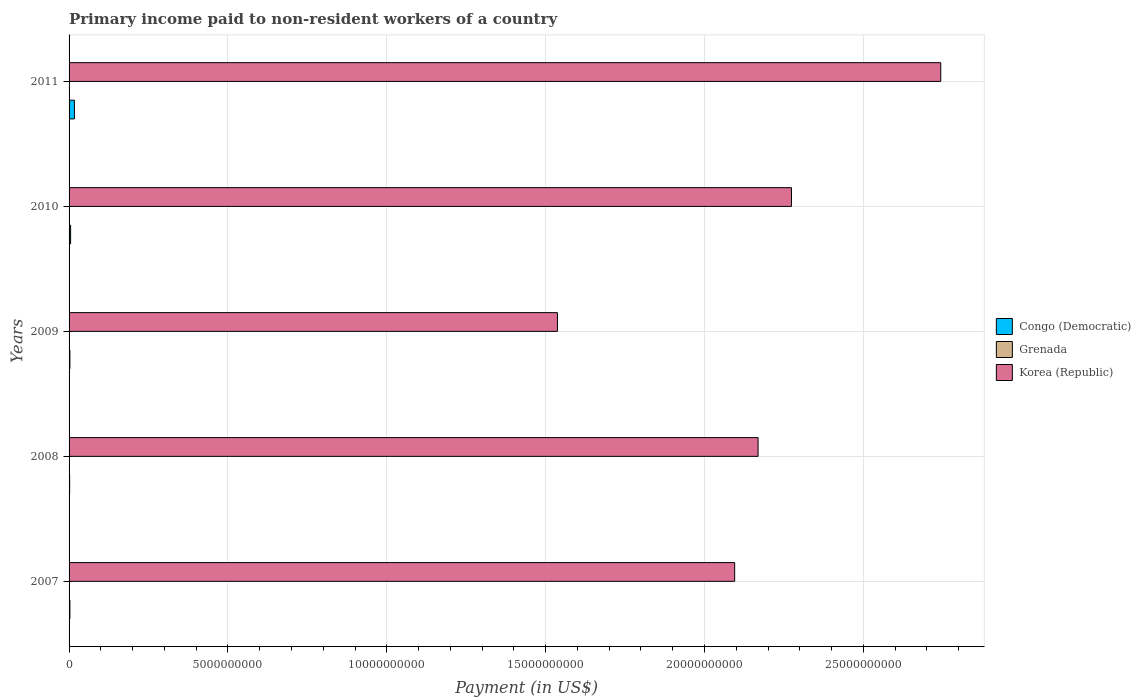How many different coloured bars are there?
Provide a short and direct response. 3. How many bars are there on the 1st tick from the top?
Your response must be concise. 3. How many bars are there on the 5th tick from the bottom?
Your response must be concise. 3. In how many cases, is the number of bars for a given year not equal to the number of legend labels?
Your answer should be very brief. 0. What is the amount paid to workers in Congo (Democratic) in 2009?
Offer a very short reply. 2.60e+07. Across all years, what is the maximum amount paid to workers in Grenada?
Give a very brief answer. 1.37e+07. Across all years, what is the minimum amount paid to workers in Grenada?
Offer a very short reply. 5.77e+06. In which year was the amount paid to workers in Congo (Democratic) minimum?
Give a very brief answer. 2008. What is the total amount paid to workers in Congo (Democratic) in the graph?
Provide a short and direct response. 2.86e+08. What is the difference between the amount paid to workers in Korea (Republic) in 2007 and that in 2011?
Offer a terse response. -6.49e+09. What is the difference between the amount paid to workers in Congo (Democratic) in 2011 and the amount paid to workers in Korea (Republic) in 2008?
Make the answer very short. -2.15e+1. What is the average amount paid to workers in Congo (Democratic) per year?
Provide a short and direct response. 5.73e+07. In the year 2011, what is the difference between the amount paid to workers in Korea (Republic) and amount paid to workers in Grenada?
Your response must be concise. 2.74e+1. In how many years, is the amount paid to workers in Korea (Republic) greater than 25000000000 US$?
Offer a very short reply. 1. What is the ratio of the amount paid to workers in Congo (Democratic) in 2009 to that in 2011?
Offer a very short reply. 0.15. What is the difference between the highest and the second highest amount paid to workers in Grenada?
Provide a short and direct response. 5.54e+06. What is the difference between the highest and the lowest amount paid to workers in Congo (Democratic)?
Your answer should be very brief. 1.50e+08. In how many years, is the amount paid to workers in Korea (Republic) greater than the average amount paid to workers in Korea (Republic) taken over all years?
Your response must be concise. 3. What does the 2nd bar from the top in 2010 represents?
Make the answer very short. Grenada. What does the 1st bar from the bottom in 2007 represents?
Offer a terse response. Congo (Democratic). Are all the bars in the graph horizontal?
Your response must be concise. Yes. How many years are there in the graph?
Make the answer very short. 5. Are the values on the major ticks of X-axis written in scientific E-notation?
Make the answer very short. No. Does the graph contain grids?
Give a very brief answer. Yes. How many legend labels are there?
Provide a short and direct response. 3. What is the title of the graph?
Provide a short and direct response. Primary income paid to non-resident workers of a country. What is the label or title of the X-axis?
Offer a terse response. Payment (in US$). What is the Payment (in US$) in Congo (Democratic) in 2007?
Make the answer very short. 2.60e+07. What is the Payment (in US$) of Grenada in 2007?
Your response must be concise. 1.37e+07. What is the Payment (in US$) in Korea (Republic) in 2007?
Offer a terse response. 2.09e+1. What is the Payment (in US$) in Congo (Democratic) in 2008?
Ensure brevity in your answer.  1.78e+07. What is the Payment (in US$) in Grenada in 2008?
Ensure brevity in your answer.  8.08e+06. What is the Payment (in US$) of Korea (Republic) in 2008?
Make the answer very short. 2.17e+1. What is the Payment (in US$) in Congo (Democratic) in 2009?
Offer a very short reply. 2.60e+07. What is the Payment (in US$) in Grenada in 2009?
Make the answer very short. 8.12e+06. What is the Payment (in US$) of Korea (Republic) in 2009?
Your answer should be very brief. 1.54e+1. What is the Payment (in US$) in Congo (Democratic) in 2010?
Ensure brevity in your answer.  4.83e+07. What is the Payment (in US$) in Grenada in 2010?
Provide a succinct answer. 7.15e+06. What is the Payment (in US$) in Korea (Republic) in 2010?
Your answer should be very brief. 2.27e+1. What is the Payment (in US$) of Congo (Democratic) in 2011?
Your answer should be compact. 1.68e+08. What is the Payment (in US$) in Grenada in 2011?
Your answer should be compact. 5.77e+06. What is the Payment (in US$) in Korea (Republic) in 2011?
Make the answer very short. 2.74e+1. Across all years, what is the maximum Payment (in US$) of Congo (Democratic)?
Provide a succinct answer. 1.68e+08. Across all years, what is the maximum Payment (in US$) in Grenada?
Ensure brevity in your answer.  1.37e+07. Across all years, what is the maximum Payment (in US$) of Korea (Republic)?
Keep it short and to the point. 2.74e+1. Across all years, what is the minimum Payment (in US$) of Congo (Democratic)?
Ensure brevity in your answer.  1.78e+07. Across all years, what is the minimum Payment (in US$) of Grenada?
Provide a short and direct response. 5.77e+06. Across all years, what is the minimum Payment (in US$) of Korea (Republic)?
Your answer should be compact. 1.54e+1. What is the total Payment (in US$) of Congo (Democratic) in the graph?
Ensure brevity in your answer.  2.86e+08. What is the total Payment (in US$) in Grenada in the graph?
Make the answer very short. 4.28e+07. What is the total Payment (in US$) of Korea (Republic) in the graph?
Your answer should be compact. 1.08e+11. What is the difference between the Payment (in US$) of Congo (Democratic) in 2007 and that in 2008?
Offer a terse response. 8.20e+06. What is the difference between the Payment (in US$) in Grenada in 2007 and that in 2008?
Offer a very short reply. 5.58e+06. What is the difference between the Payment (in US$) of Korea (Republic) in 2007 and that in 2008?
Your answer should be very brief. -7.37e+08. What is the difference between the Payment (in US$) in Congo (Democratic) in 2007 and that in 2009?
Provide a succinct answer. 0. What is the difference between the Payment (in US$) of Grenada in 2007 and that in 2009?
Your answer should be compact. 5.54e+06. What is the difference between the Payment (in US$) of Korea (Republic) in 2007 and that in 2009?
Make the answer very short. 5.58e+09. What is the difference between the Payment (in US$) of Congo (Democratic) in 2007 and that in 2010?
Ensure brevity in your answer.  -2.23e+07. What is the difference between the Payment (in US$) in Grenada in 2007 and that in 2010?
Keep it short and to the point. 6.51e+06. What is the difference between the Payment (in US$) of Korea (Republic) in 2007 and that in 2010?
Offer a very short reply. -1.79e+09. What is the difference between the Payment (in US$) in Congo (Democratic) in 2007 and that in 2011?
Your answer should be compact. -1.42e+08. What is the difference between the Payment (in US$) in Grenada in 2007 and that in 2011?
Your answer should be compact. 7.89e+06. What is the difference between the Payment (in US$) in Korea (Republic) in 2007 and that in 2011?
Offer a terse response. -6.49e+09. What is the difference between the Payment (in US$) of Congo (Democratic) in 2008 and that in 2009?
Offer a very short reply. -8.20e+06. What is the difference between the Payment (in US$) in Grenada in 2008 and that in 2009?
Your answer should be very brief. -4.16e+04. What is the difference between the Payment (in US$) of Korea (Republic) in 2008 and that in 2009?
Your answer should be very brief. 6.31e+09. What is the difference between the Payment (in US$) of Congo (Democratic) in 2008 and that in 2010?
Ensure brevity in your answer.  -3.05e+07. What is the difference between the Payment (in US$) in Grenada in 2008 and that in 2010?
Make the answer very short. 9.31e+05. What is the difference between the Payment (in US$) in Korea (Republic) in 2008 and that in 2010?
Provide a short and direct response. -1.05e+09. What is the difference between the Payment (in US$) in Congo (Democratic) in 2008 and that in 2011?
Your answer should be very brief. -1.50e+08. What is the difference between the Payment (in US$) of Grenada in 2008 and that in 2011?
Make the answer very short. 2.31e+06. What is the difference between the Payment (in US$) in Korea (Republic) in 2008 and that in 2011?
Offer a very short reply. -5.75e+09. What is the difference between the Payment (in US$) of Congo (Democratic) in 2009 and that in 2010?
Give a very brief answer. -2.23e+07. What is the difference between the Payment (in US$) of Grenada in 2009 and that in 2010?
Keep it short and to the point. 9.73e+05. What is the difference between the Payment (in US$) in Korea (Republic) in 2009 and that in 2010?
Provide a succinct answer. -7.37e+09. What is the difference between the Payment (in US$) of Congo (Democratic) in 2009 and that in 2011?
Provide a succinct answer. -1.42e+08. What is the difference between the Payment (in US$) of Grenada in 2009 and that in 2011?
Offer a terse response. 2.35e+06. What is the difference between the Payment (in US$) of Korea (Republic) in 2009 and that in 2011?
Keep it short and to the point. -1.21e+1. What is the difference between the Payment (in US$) in Congo (Democratic) in 2010 and that in 2011?
Your answer should be compact. -1.20e+08. What is the difference between the Payment (in US$) of Grenada in 2010 and that in 2011?
Provide a short and direct response. 1.38e+06. What is the difference between the Payment (in US$) in Korea (Republic) in 2010 and that in 2011?
Offer a very short reply. -4.70e+09. What is the difference between the Payment (in US$) in Congo (Democratic) in 2007 and the Payment (in US$) in Grenada in 2008?
Your answer should be compact. 1.79e+07. What is the difference between the Payment (in US$) of Congo (Democratic) in 2007 and the Payment (in US$) of Korea (Republic) in 2008?
Make the answer very short. -2.17e+1. What is the difference between the Payment (in US$) of Grenada in 2007 and the Payment (in US$) of Korea (Republic) in 2008?
Offer a terse response. -2.17e+1. What is the difference between the Payment (in US$) in Congo (Democratic) in 2007 and the Payment (in US$) in Grenada in 2009?
Provide a succinct answer. 1.79e+07. What is the difference between the Payment (in US$) of Congo (Democratic) in 2007 and the Payment (in US$) of Korea (Republic) in 2009?
Make the answer very short. -1.53e+1. What is the difference between the Payment (in US$) of Grenada in 2007 and the Payment (in US$) of Korea (Republic) in 2009?
Your answer should be compact. -1.54e+1. What is the difference between the Payment (in US$) of Congo (Democratic) in 2007 and the Payment (in US$) of Grenada in 2010?
Your response must be concise. 1.88e+07. What is the difference between the Payment (in US$) in Congo (Democratic) in 2007 and the Payment (in US$) in Korea (Republic) in 2010?
Your response must be concise. -2.27e+1. What is the difference between the Payment (in US$) in Grenada in 2007 and the Payment (in US$) in Korea (Republic) in 2010?
Your answer should be very brief. -2.27e+1. What is the difference between the Payment (in US$) in Congo (Democratic) in 2007 and the Payment (in US$) in Grenada in 2011?
Your answer should be compact. 2.02e+07. What is the difference between the Payment (in US$) of Congo (Democratic) in 2007 and the Payment (in US$) of Korea (Republic) in 2011?
Offer a very short reply. -2.74e+1. What is the difference between the Payment (in US$) in Grenada in 2007 and the Payment (in US$) in Korea (Republic) in 2011?
Your response must be concise. -2.74e+1. What is the difference between the Payment (in US$) in Congo (Democratic) in 2008 and the Payment (in US$) in Grenada in 2009?
Your answer should be compact. 9.68e+06. What is the difference between the Payment (in US$) in Congo (Democratic) in 2008 and the Payment (in US$) in Korea (Republic) in 2009?
Give a very brief answer. -1.54e+1. What is the difference between the Payment (in US$) of Grenada in 2008 and the Payment (in US$) of Korea (Republic) in 2009?
Give a very brief answer. -1.54e+1. What is the difference between the Payment (in US$) in Congo (Democratic) in 2008 and the Payment (in US$) in Grenada in 2010?
Offer a terse response. 1.06e+07. What is the difference between the Payment (in US$) of Congo (Democratic) in 2008 and the Payment (in US$) of Korea (Republic) in 2010?
Offer a very short reply. -2.27e+1. What is the difference between the Payment (in US$) of Grenada in 2008 and the Payment (in US$) of Korea (Republic) in 2010?
Make the answer very short. -2.27e+1. What is the difference between the Payment (in US$) of Congo (Democratic) in 2008 and the Payment (in US$) of Grenada in 2011?
Give a very brief answer. 1.20e+07. What is the difference between the Payment (in US$) in Congo (Democratic) in 2008 and the Payment (in US$) in Korea (Republic) in 2011?
Provide a short and direct response. -2.74e+1. What is the difference between the Payment (in US$) in Grenada in 2008 and the Payment (in US$) in Korea (Republic) in 2011?
Your answer should be compact. -2.74e+1. What is the difference between the Payment (in US$) of Congo (Democratic) in 2009 and the Payment (in US$) of Grenada in 2010?
Offer a very short reply. 1.88e+07. What is the difference between the Payment (in US$) in Congo (Democratic) in 2009 and the Payment (in US$) in Korea (Republic) in 2010?
Your answer should be compact. -2.27e+1. What is the difference between the Payment (in US$) of Grenada in 2009 and the Payment (in US$) of Korea (Republic) in 2010?
Keep it short and to the point. -2.27e+1. What is the difference between the Payment (in US$) in Congo (Democratic) in 2009 and the Payment (in US$) in Grenada in 2011?
Offer a terse response. 2.02e+07. What is the difference between the Payment (in US$) of Congo (Democratic) in 2009 and the Payment (in US$) of Korea (Republic) in 2011?
Ensure brevity in your answer.  -2.74e+1. What is the difference between the Payment (in US$) of Grenada in 2009 and the Payment (in US$) of Korea (Republic) in 2011?
Make the answer very short. -2.74e+1. What is the difference between the Payment (in US$) of Congo (Democratic) in 2010 and the Payment (in US$) of Grenada in 2011?
Your answer should be very brief. 4.25e+07. What is the difference between the Payment (in US$) of Congo (Democratic) in 2010 and the Payment (in US$) of Korea (Republic) in 2011?
Make the answer very short. -2.74e+1. What is the difference between the Payment (in US$) of Grenada in 2010 and the Payment (in US$) of Korea (Republic) in 2011?
Offer a very short reply. -2.74e+1. What is the average Payment (in US$) in Congo (Democratic) per year?
Your answer should be compact. 5.73e+07. What is the average Payment (in US$) of Grenada per year?
Make the answer very short. 8.56e+06. What is the average Payment (in US$) in Korea (Republic) per year?
Your response must be concise. 2.16e+1. In the year 2007, what is the difference between the Payment (in US$) in Congo (Democratic) and Payment (in US$) in Grenada?
Your response must be concise. 1.23e+07. In the year 2007, what is the difference between the Payment (in US$) in Congo (Democratic) and Payment (in US$) in Korea (Republic)?
Keep it short and to the point. -2.09e+1. In the year 2007, what is the difference between the Payment (in US$) in Grenada and Payment (in US$) in Korea (Republic)?
Your response must be concise. -2.09e+1. In the year 2008, what is the difference between the Payment (in US$) of Congo (Democratic) and Payment (in US$) of Grenada?
Give a very brief answer. 9.72e+06. In the year 2008, what is the difference between the Payment (in US$) in Congo (Democratic) and Payment (in US$) in Korea (Republic)?
Offer a terse response. -2.17e+1. In the year 2008, what is the difference between the Payment (in US$) in Grenada and Payment (in US$) in Korea (Republic)?
Provide a short and direct response. -2.17e+1. In the year 2009, what is the difference between the Payment (in US$) in Congo (Democratic) and Payment (in US$) in Grenada?
Give a very brief answer. 1.79e+07. In the year 2009, what is the difference between the Payment (in US$) of Congo (Democratic) and Payment (in US$) of Korea (Republic)?
Ensure brevity in your answer.  -1.53e+1. In the year 2009, what is the difference between the Payment (in US$) in Grenada and Payment (in US$) in Korea (Republic)?
Keep it short and to the point. -1.54e+1. In the year 2010, what is the difference between the Payment (in US$) of Congo (Democratic) and Payment (in US$) of Grenada?
Your answer should be compact. 4.11e+07. In the year 2010, what is the difference between the Payment (in US$) in Congo (Democratic) and Payment (in US$) in Korea (Republic)?
Your answer should be compact. -2.27e+1. In the year 2010, what is the difference between the Payment (in US$) of Grenada and Payment (in US$) of Korea (Republic)?
Your answer should be compact. -2.27e+1. In the year 2011, what is the difference between the Payment (in US$) of Congo (Democratic) and Payment (in US$) of Grenada?
Provide a short and direct response. 1.62e+08. In the year 2011, what is the difference between the Payment (in US$) of Congo (Democratic) and Payment (in US$) of Korea (Republic)?
Your answer should be compact. -2.73e+1. In the year 2011, what is the difference between the Payment (in US$) in Grenada and Payment (in US$) in Korea (Republic)?
Offer a terse response. -2.74e+1. What is the ratio of the Payment (in US$) of Congo (Democratic) in 2007 to that in 2008?
Give a very brief answer. 1.46. What is the ratio of the Payment (in US$) of Grenada in 2007 to that in 2008?
Keep it short and to the point. 1.69. What is the ratio of the Payment (in US$) of Congo (Democratic) in 2007 to that in 2009?
Ensure brevity in your answer.  1. What is the ratio of the Payment (in US$) of Grenada in 2007 to that in 2009?
Provide a succinct answer. 1.68. What is the ratio of the Payment (in US$) of Korea (Republic) in 2007 to that in 2009?
Your answer should be compact. 1.36. What is the ratio of the Payment (in US$) in Congo (Democratic) in 2007 to that in 2010?
Your response must be concise. 0.54. What is the ratio of the Payment (in US$) in Grenada in 2007 to that in 2010?
Ensure brevity in your answer.  1.91. What is the ratio of the Payment (in US$) in Korea (Republic) in 2007 to that in 2010?
Make the answer very short. 0.92. What is the ratio of the Payment (in US$) of Congo (Democratic) in 2007 to that in 2011?
Offer a terse response. 0.15. What is the ratio of the Payment (in US$) in Grenada in 2007 to that in 2011?
Make the answer very short. 2.37. What is the ratio of the Payment (in US$) of Korea (Republic) in 2007 to that in 2011?
Keep it short and to the point. 0.76. What is the ratio of the Payment (in US$) of Congo (Democratic) in 2008 to that in 2009?
Ensure brevity in your answer.  0.68. What is the ratio of the Payment (in US$) of Korea (Republic) in 2008 to that in 2009?
Offer a very short reply. 1.41. What is the ratio of the Payment (in US$) in Congo (Democratic) in 2008 to that in 2010?
Give a very brief answer. 0.37. What is the ratio of the Payment (in US$) of Grenada in 2008 to that in 2010?
Offer a very short reply. 1.13. What is the ratio of the Payment (in US$) of Korea (Republic) in 2008 to that in 2010?
Offer a terse response. 0.95. What is the ratio of the Payment (in US$) of Congo (Democratic) in 2008 to that in 2011?
Offer a terse response. 0.11. What is the ratio of the Payment (in US$) in Grenada in 2008 to that in 2011?
Make the answer very short. 1.4. What is the ratio of the Payment (in US$) of Korea (Republic) in 2008 to that in 2011?
Ensure brevity in your answer.  0.79. What is the ratio of the Payment (in US$) in Congo (Democratic) in 2009 to that in 2010?
Make the answer very short. 0.54. What is the ratio of the Payment (in US$) of Grenada in 2009 to that in 2010?
Offer a terse response. 1.14. What is the ratio of the Payment (in US$) in Korea (Republic) in 2009 to that in 2010?
Your response must be concise. 0.68. What is the ratio of the Payment (in US$) in Congo (Democratic) in 2009 to that in 2011?
Offer a very short reply. 0.15. What is the ratio of the Payment (in US$) of Grenada in 2009 to that in 2011?
Provide a short and direct response. 1.41. What is the ratio of the Payment (in US$) in Korea (Republic) in 2009 to that in 2011?
Ensure brevity in your answer.  0.56. What is the ratio of the Payment (in US$) of Congo (Democratic) in 2010 to that in 2011?
Provide a short and direct response. 0.29. What is the ratio of the Payment (in US$) in Grenada in 2010 to that in 2011?
Provide a short and direct response. 1.24. What is the ratio of the Payment (in US$) of Korea (Republic) in 2010 to that in 2011?
Give a very brief answer. 0.83. What is the difference between the highest and the second highest Payment (in US$) in Congo (Democratic)?
Give a very brief answer. 1.20e+08. What is the difference between the highest and the second highest Payment (in US$) of Grenada?
Offer a very short reply. 5.54e+06. What is the difference between the highest and the second highest Payment (in US$) of Korea (Republic)?
Ensure brevity in your answer.  4.70e+09. What is the difference between the highest and the lowest Payment (in US$) of Congo (Democratic)?
Your response must be concise. 1.50e+08. What is the difference between the highest and the lowest Payment (in US$) of Grenada?
Provide a short and direct response. 7.89e+06. What is the difference between the highest and the lowest Payment (in US$) in Korea (Republic)?
Give a very brief answer. 1.21e+1. 